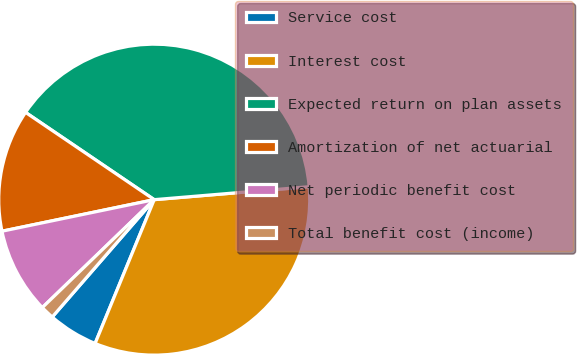<chart> <loc_0><loc_0><loc_500><loc_500><pie_chart><fcel>Service cost<fcel>Interest cost<fcel>Expected return on plan assets<fcel>Amortization of net actuarial<fcel>Net periodic benefit cost<fcel>Total benefit cost (income)<nl><fcel>5.18%<fcel>32.54%<fcel>39.19%<fcel>12.74%<fcel>8.96%<fcel>1.4%<nl></chart> 